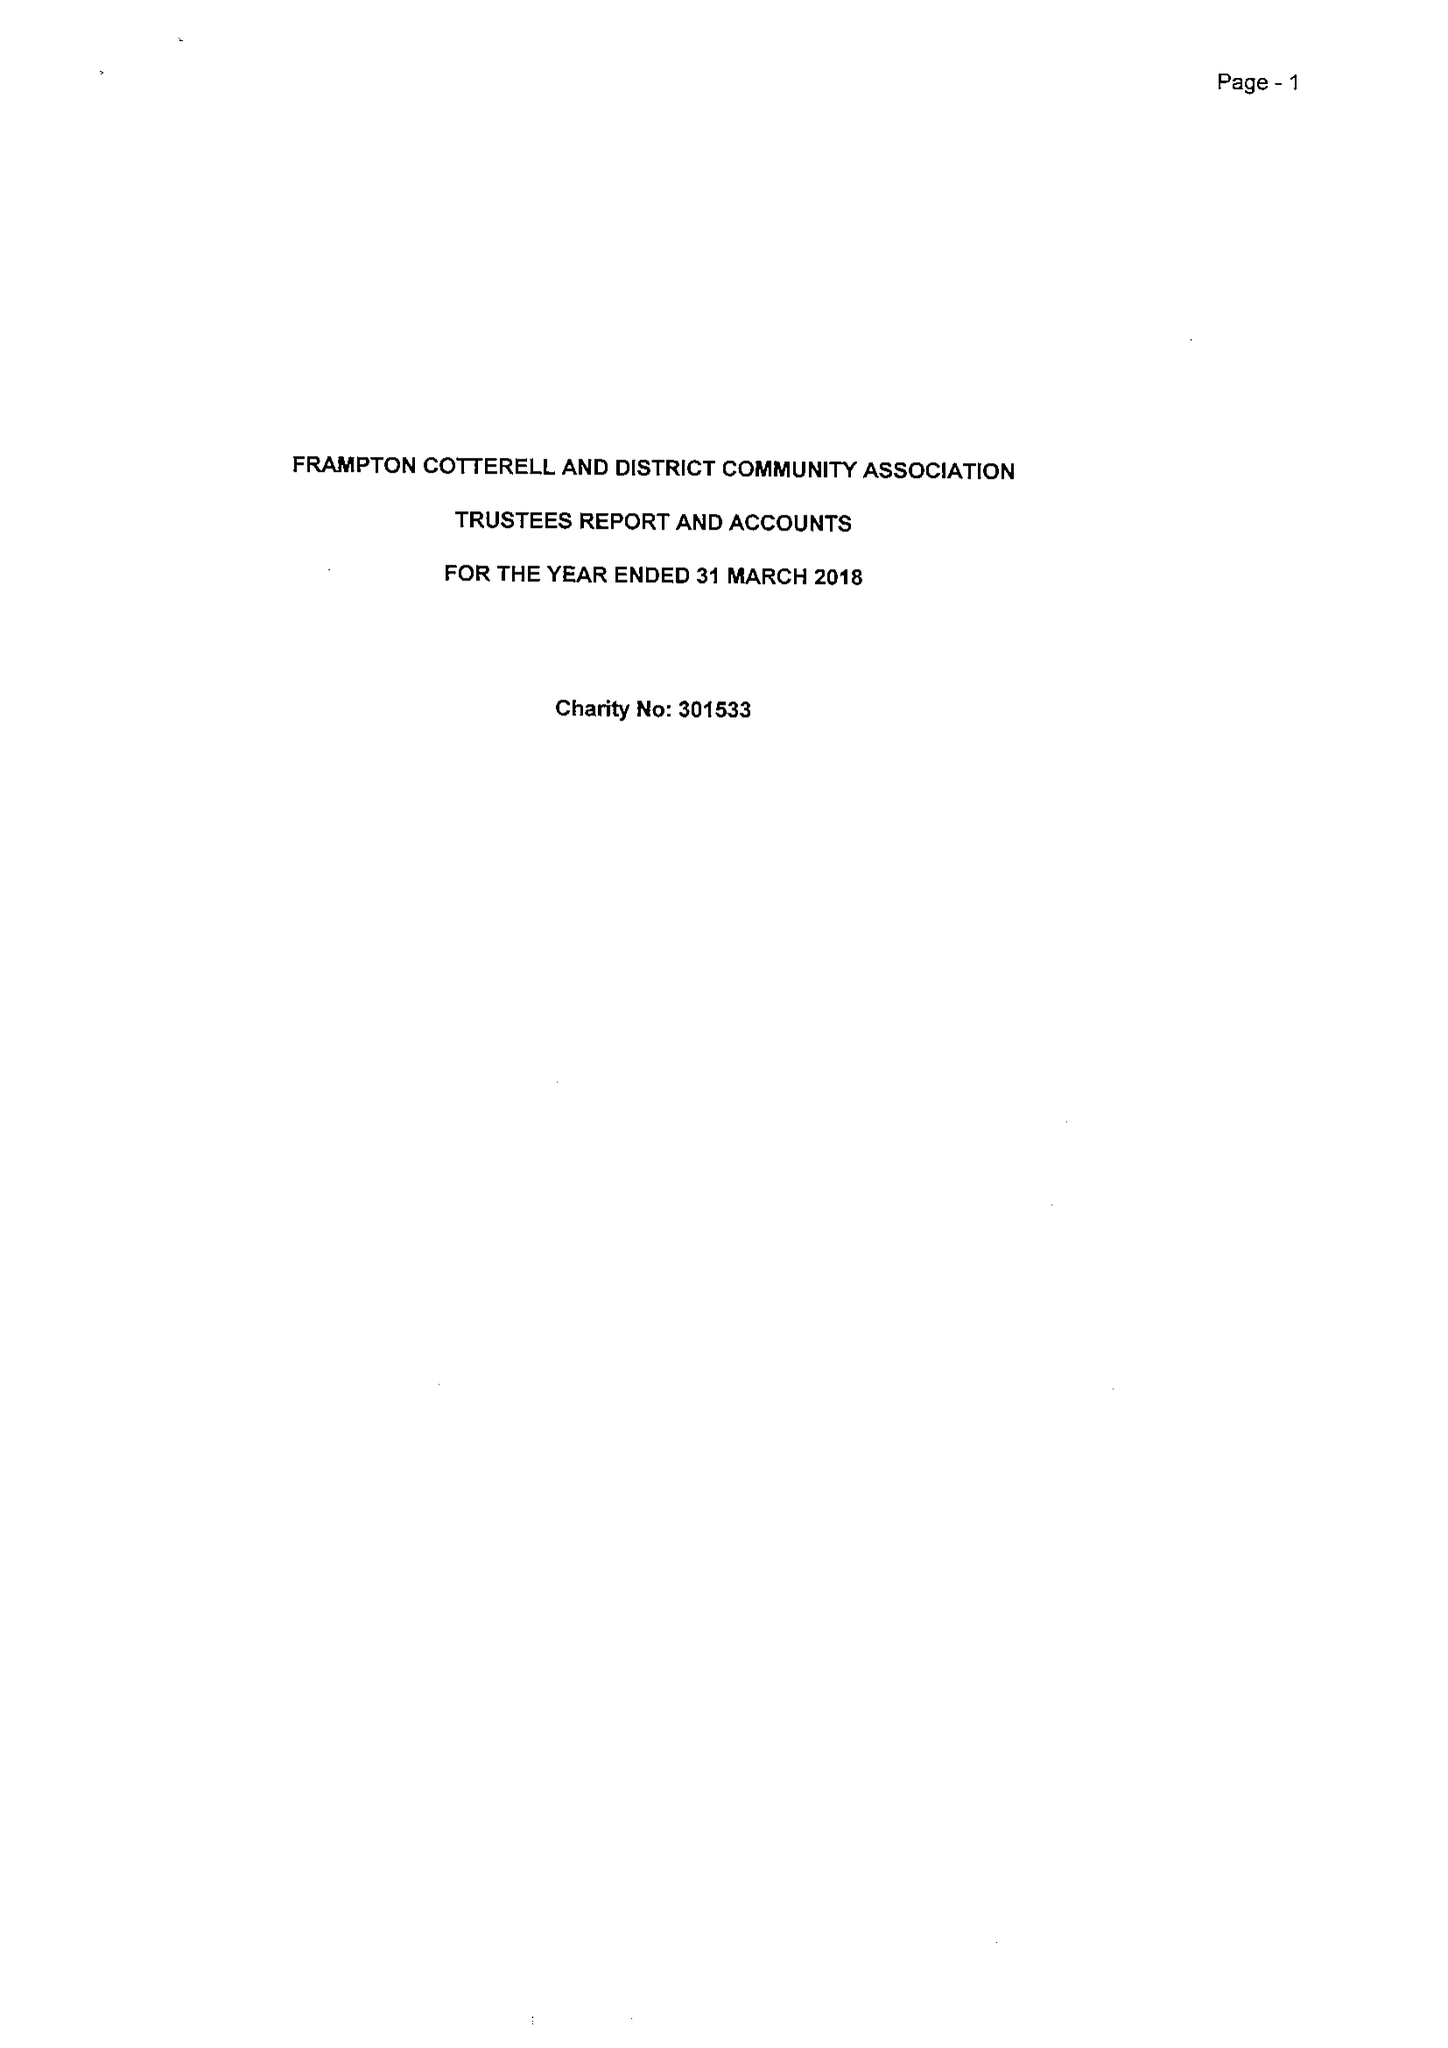What is the value for the address__postcode?
Answer the question using a single word or phrase. BS36 2DB 